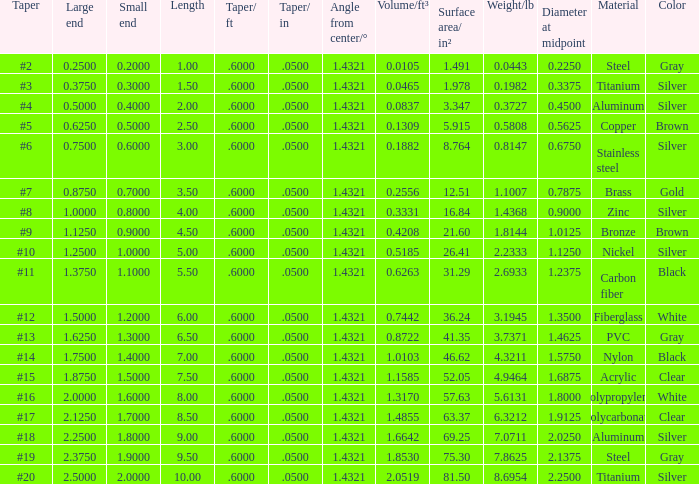Which Length has a Taper of #15, and a Large end larger than 1.875? None. 